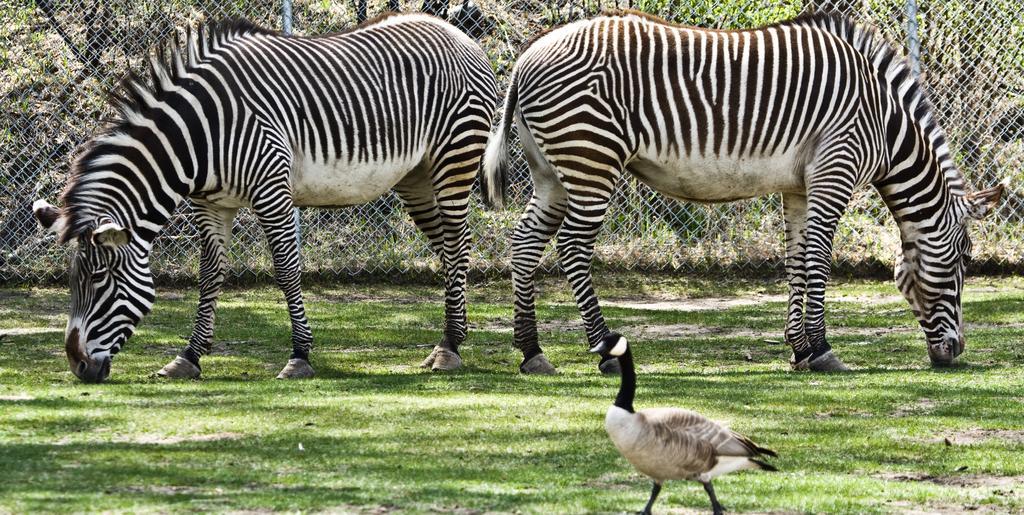How would you summarize this image in a sentence or two? In this given image, We can see a garden and two Zebras standing, a bird after that, We can see a boundary wall which is build with an iron grill, a grass. 